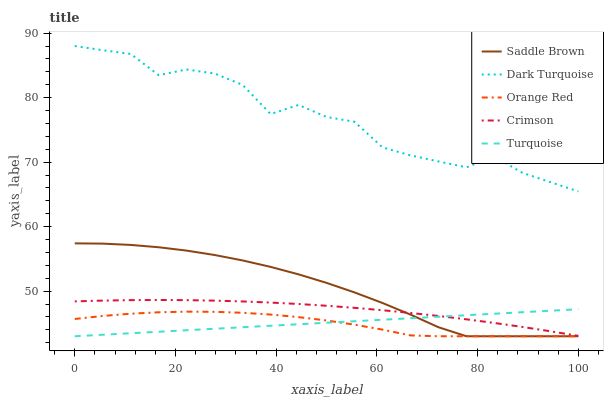Does Orange Red have the minimum area under the curve?
Answer yes or no. Yes. Does Dark Turquoise have the maximum area under the curve?
Answer yes or no. Yes. Does Turquoise have the minimum area under the curve?
Answer yes or no. No. Does Turquoise have the maximum area under the curve?
Answer yes or no. No. Is Turquoise the smoothest?
Answer yes or no. Yes. Is Dark Turquoise the roughest?
Answer yes or no. Yes. Is Dark Turquoise the smoothest?
Answer yes or no. No. Is Turquoise the roughest?
Answer yes or no. No. Does Turquoise have the lowest value?
Answer yes or no. Yes. Does Dark Turquoise have the lowest value?
Answer yes or no. No. Does Dark Turquoise have the highest value?
Answer yes or no. Yes. Does Turquoise have the highest value?
Answer yes or no. No. Is Orange Red less than Dark Turquoise?
Answer yes or no. Yes. Is Dark Turquoise greater than Saddle Brown?
Answer yes or no. Yes. Does Turquoise intersect Saddle Brown?
Answer yes or no. Yes. Is Turquoise less than Saddle Brown?
Answer yes or no. No. Is Turquoise greater than Saddle Brown?
Answer yes or no. No. Does Orange Red intersect Dark Turquoise?
Answer yes or no. No. 